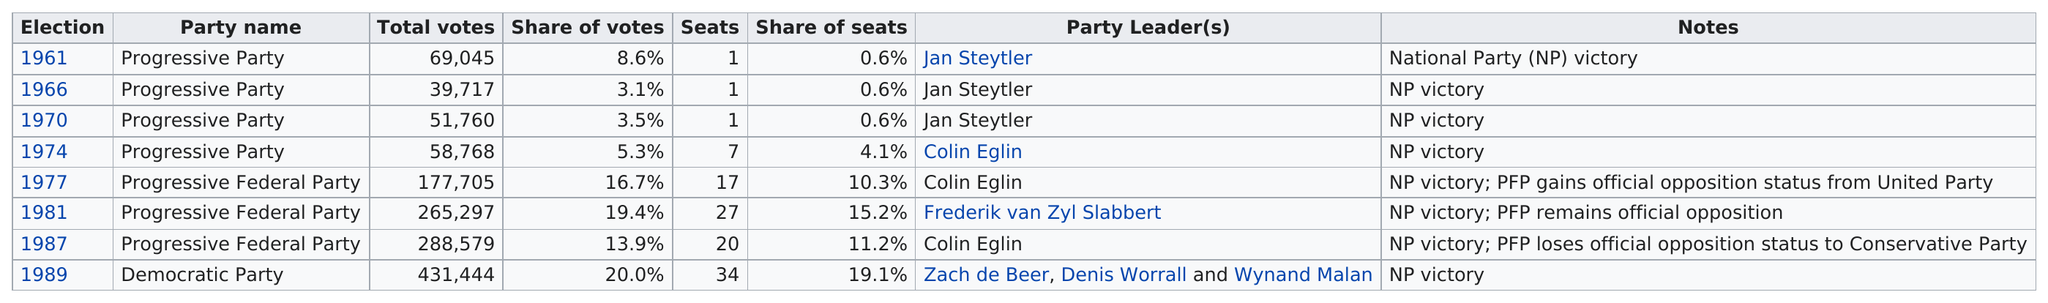List a handful of essential elements in this visual. In 1989, the election with the most total votes was held. In 1989, the Democratic Party received 431,444 votes. Jan Steytler served as the party leader three times. There are a total of 108 seats listed in the table. The Progressive Party has been listed 4 times in a row. 